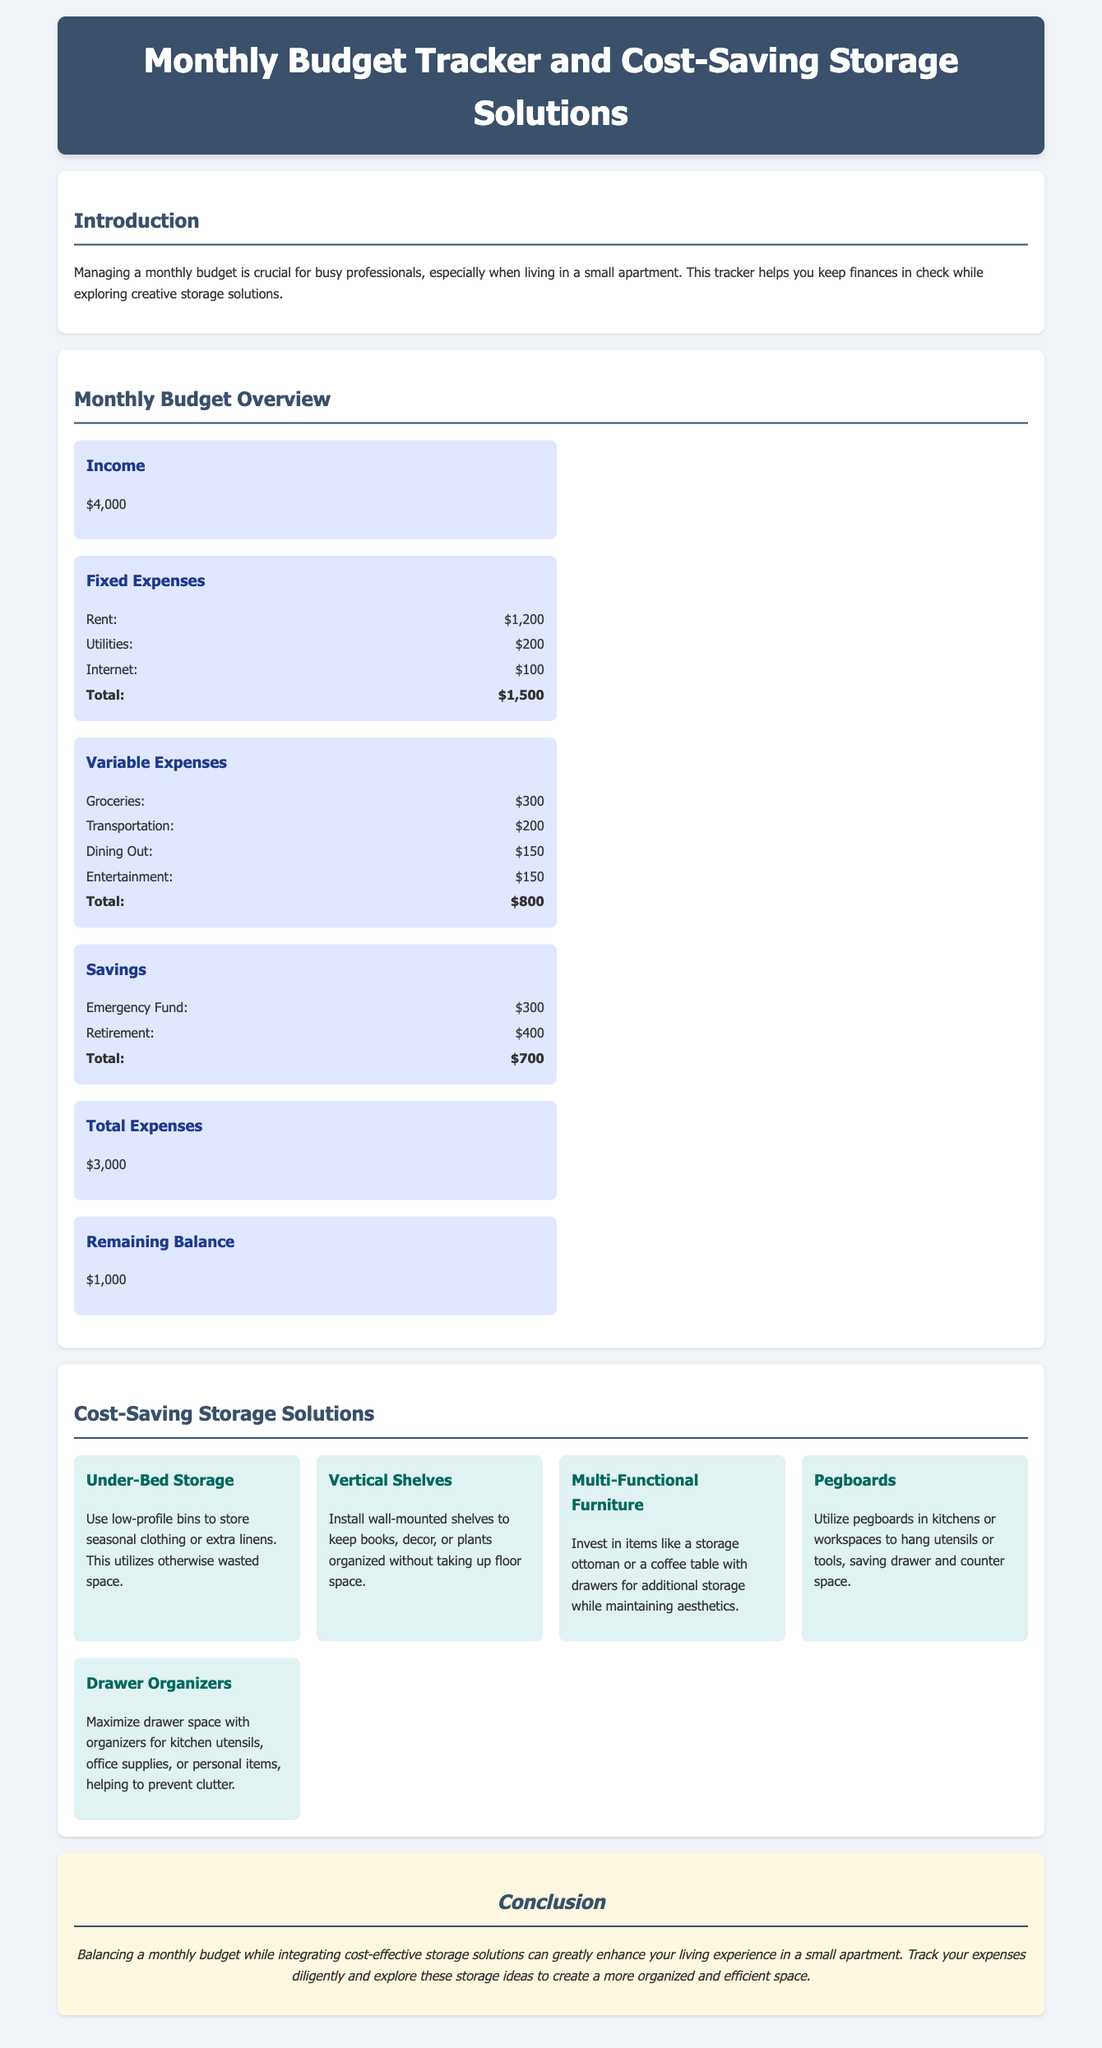What is the total income? The total income is stated in the overview section of the document as $4,000.
Answer: $4,000 What is the total of fixed expenses? The document lists the fixed expenses, and their total is calculated as $1,200 (rent) + $200 (utilities) + $100 (internet) = $1,500.
Answer: $1,500 What storage solution utilizes otherwise wasted space? The document mentions under-bed storage as a solution that uses low-profile bins for seasonal clothing or extra linens.
Answer: Under-Bed Storage How much is allocated to the emergency fund? The budget overview includes an allocation specifically for the emergency fund, which is $300.
Answer: $300 What is the remaining balance after all expenses? The document states that the remaining balance after all expenses is $1,000.
Answer: $1,000 What type of furniture is suggested for additional storage? The document mentions multi-functional furniture, such as a storage ottoman or a coffee table with drawers as creative storage solutions.
Answer: Multi-Functional Furniture Which budget category has the highest expense listed? The document shows the total fixed expenses as $1,500, which is higher than all other expense categories.
Answer: Fixed Expenses What is the total for variable expenses? The summary for variable expenses includes groceries, transportation, dining out, and entertainment, totaling $800.
Answer: $800 What color is used for section headings? The section headings in the document are styled with a color code that corresponds to the shade representing #3a506b.
Answer: #3a506b 